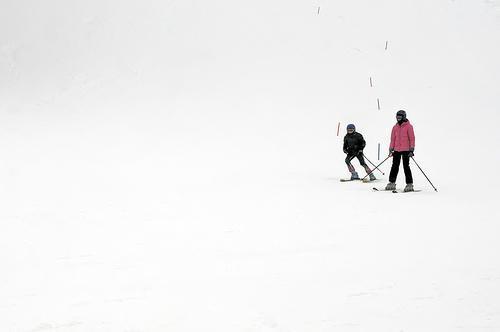How many people are there?
Give a very brief answer. 2. 